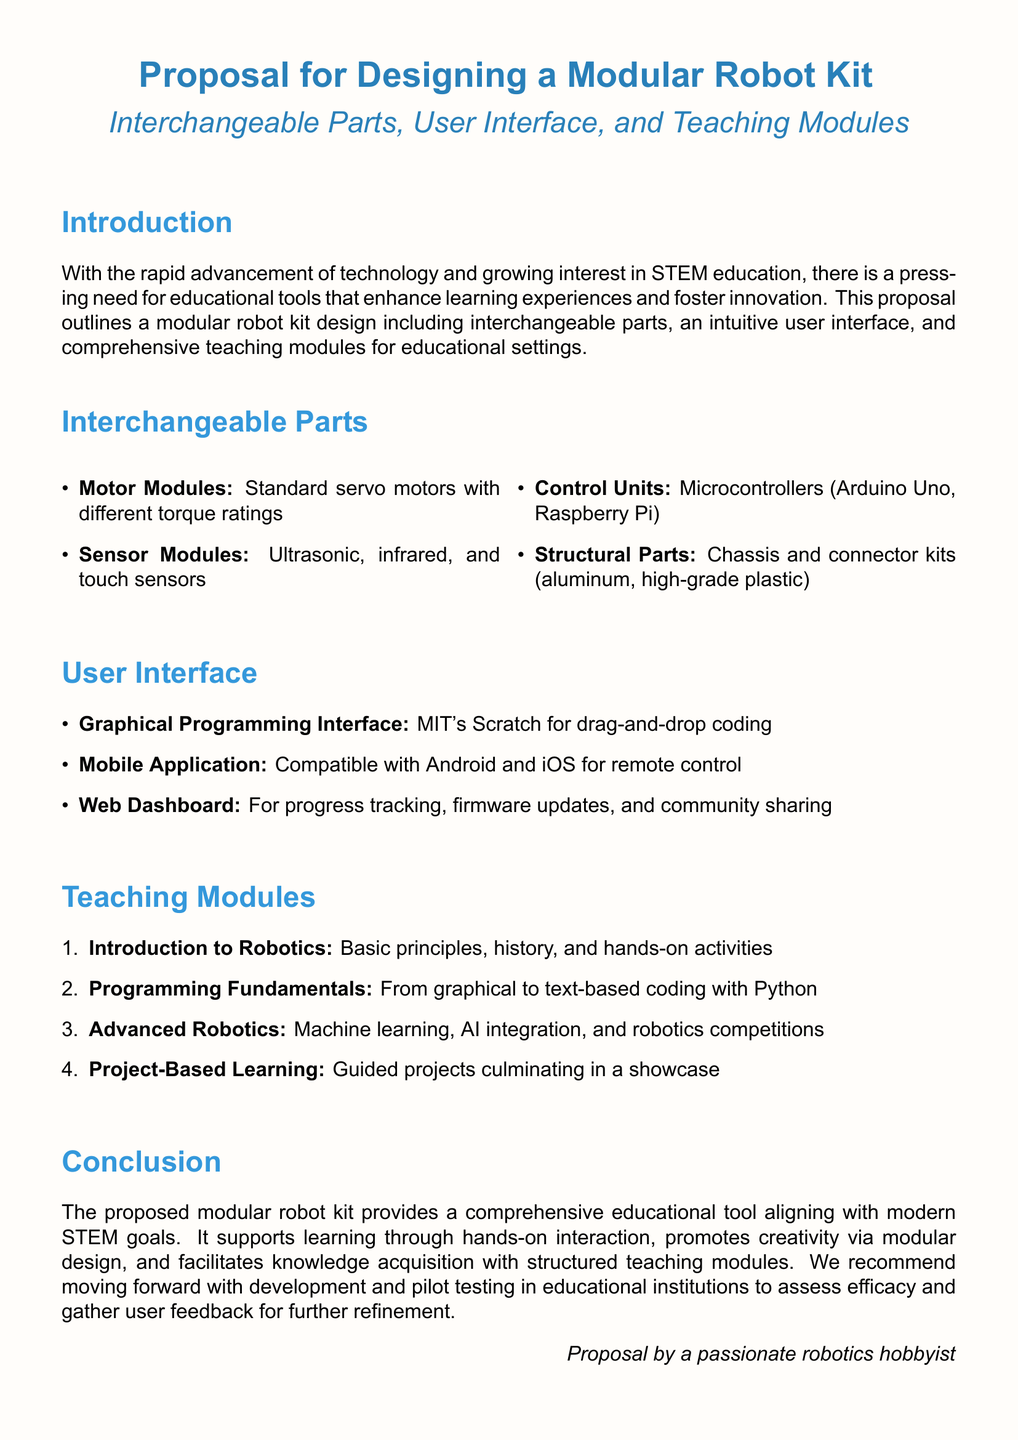What is the main focus of the proposal? The main focus of the proposal is to design a modular robot kit for educational use.
Answer: modular robot kit What are the four types of sensor modules mentioned? The types of sensor modules listed are ultrasonic, infrared, and touch sensors.
Answer: ultrasonic, infrared, touch sensors How many teaching modules are included in the proposal? The document enumerates four specific teaching modules for the proposed kit.
Answer: four What programming interface is recommended for beginners? The proposal states that MIT's Scratch will be used for drag-and-drop coding.
Answer: MIT's Scratch What material is suggested for structural parts? The proposal mentions aluminum and high-grade plastic as materials for structural parts.
Answer: aluminum, high-grade plastic What is the purpose of the mobile application? The purpose of the mobile application is for remote control.
Answer: remote control Which advanced topic is included in the teaching modules? The advanced robotics teaching module includes machine learning and AI integration.
Answer: machine learning, AI integration Who is the proposal authored by? The proposal is authored by a passionate robotics hobbyist.
Answer: passionate robotics hobbyist 